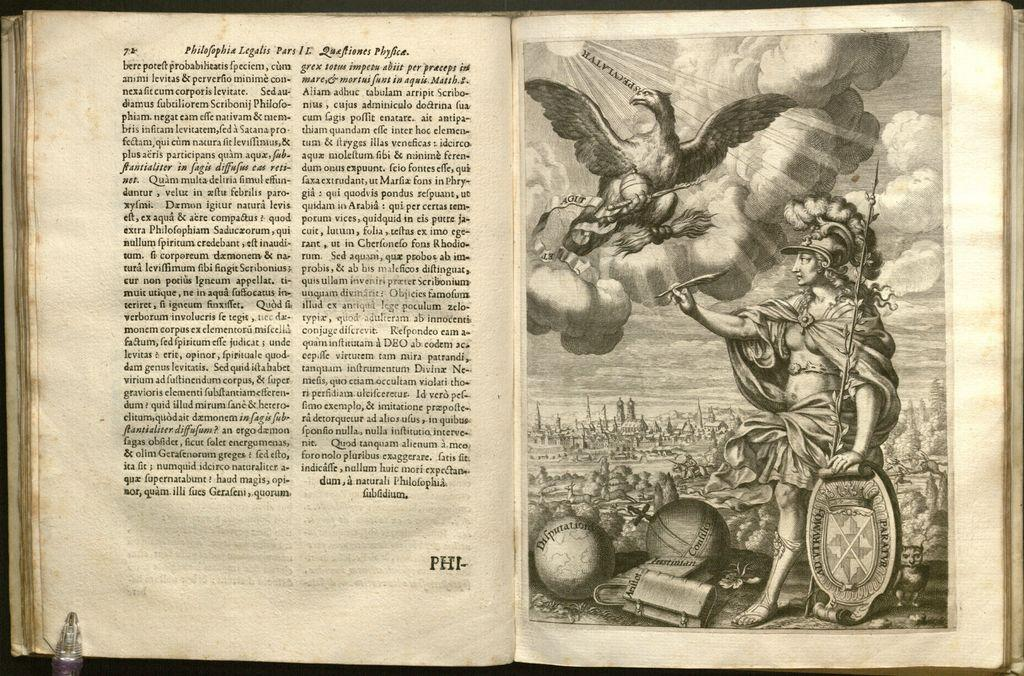What is the main subject in the center of the image? There is a book in the center of the image. What can be found inside the book? The book contains an image and text. Is there any writing instrument visible in the image? Yes, there appears to be a pen at the bottom side of the book. What type of orange can be seen on the cover of the book in the image? There is no orange visible on the cover of the book in the image. 